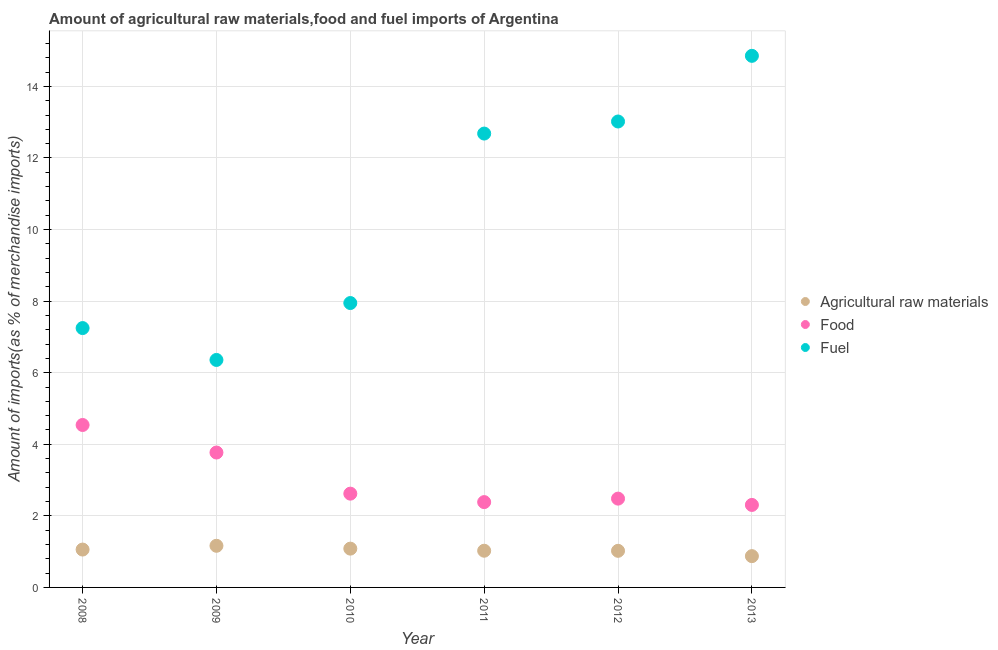How many different coloured dotlines are there?
Your response must be concise. 3. Is the number of dotlines equal to the number of legend labels?
Provide a succinct answer. Yes. What is the percentage of food imports in 2010?
Offer a terse response. 2.62. Across all years, what is the maximum percentage of food imports?
Make the answer very short. 4.54. Across all years, what is the minimum percentage of fuel imports?
Give a very brief answer. 6.36. In which year was the percentage of food imports maximum?
Provide a succinct answer. 2008. What is the total percentage of fuel imports in the graph?
Offer a terse response. 62.1. What is the difference between the percentage of fuel imports in 2012 and that in 2013?
Provide a short and direct response. -1.83. What is the difference between the percentage of raw materials imports in 2013 and the percentage of fuel imports in 2009?
Your answer should be very brief. -5.48. What is the average percentage of food imports per year?
Your answer should be compact. 3.02. In the year 2010, what is the difference between the percentage of fuel imports and percentage of food imports?
Your answer should be compact. 5.33. In how many years, is the percentage of fuel imports greater than 14.8 %?
Keep it short and to the point. 1. What is the ratio of the percentage of raw materials imports in 2009 to that in 2011?
Your answer should be very brief. 1.13. Is the difference between the percentage of fuel imports in 2008 and 2010 greater than the difference between the percentage of food imports in 2008 and 2010?
Offer a terse response. No. What is the difference between the highest and the second highest percentage of raw materials imports?
Give a very brief answer. 0.08. What is the difference between the highest and the lowest percentage of raw materials imports?
Your answer should be very brief. 0.29. Is the percentage of raw materials imports strictly greater than the percentage of fuel imports over the years?
Offer a terse response. No. How many dotlines are there?
Make the answer very short. 3. Does the graph contain any zero values?
Offer a terse response. No. Where does the legend appear in the graph?
Provide a succinct answer. Center right. How many legend labels are there?
Make the answer very short. 3. How are the legend labels stacked?
Make the answer very short. Vertical. What is the title of the graph?
Provide a succinct answer. Amount of agricultural raw materials,food and fuel imports of Argentina. What is the label or title of the X-axis?
Your answer should be compact. Year. What is the label or title of the Y-axis?
Make the answer very short. Amount of imports(as % of merchandise imports). What is the Amount of imports(as % of merchandise imports) in Agricultural raw materials in 2008?
Keep it short and to the point. 1.06. What is the Amount of imports(as % of merchandise imports) in Food in 2008?
Keep it short and to the point. 4.54. What is the Amount of imports(as % of merchandise imports) of Fuel in 2008?
Give a very brief answer. 7.25. What is the Amount of imports(as % of merchandise imports) of Agricultural raw materials in 2009?
Provide a succinct answer. 1.16. What is the Amount of imports(as % of merchandise imports) of Food in 2009?
Offer a very short reply. 3.77. What is the Amount of imports(as % of merchandise imports) in Fuel in 2009?
Your answer should be very brief. 6.36. What is the Amount of imports(as % of merchandise imports) of Agricultural raw materials in 2010?
Provide a succinct answer. 1.08. What is the Amount of imports(as % of merchandise imports) of Food in 2010?
Offer a terse response. 2.62. What is the Amount of imports(as % of merchandise imports) of Fuel in 2010?
Keep it short and to the point. 7.95. What is the Amount of imports(as % of merchandise imports) in Agricultural raw materials in 2011?
Offer a very short reply. 1.03. What is the Amount of imports(as % of merchandise imports) in Food in 2011?
Ensure brevity in your answer.  2.38. What is the Amount of imports(as % of merchandise imports) of Fuel in 2011?
Offer a terse response. 12.68. What is the Amount of imports(as % of merchandise imports) of Agricultural raw materials in 2012?
Make the answer very short. 1.02. What is the Amount of imports(as % of merchandise imports) of Food in 2012?
Give a very brief answer. 2.48. What is the Amount of imports(as % of merchandise imports) in Fuel in 2012?
Provide a short and direct response. 13.02. What is the Amount of imports(as % of merchandise imports) of Agricultural raw materials in 2013?
Provide a succinct answer. 0.87. What is the Amount of imports(as % of merchandise imports) of Food in 2013?
Ensure brevity in your answer.  2.31. What is the Amount of imports(as % of merchandise imports) of Fuel in 2013?
Offer a terse response. 14.85. Across all years, what is the maximum Amount of imports(as % of merchandise imports) of Agricultural raw materials?
Provide a succinct answer. 1.16. Across all years, what is the maximum Amount of imports(as % of merchandise imports) in Food?
Provide a succinct answer. 4.54. Across all years, what is the maximum Amount of imports(as % of merchandise imports) in Fuel?
Keep it short and to the point. 14.85. Across all years, what is the minimum Amount of imports(as % of merchandise imports) of Agricultural raw materials?
Your answer should be very brief. 0.87. Across all years, what is the minimum Amount of imports(as % of merchandise imports) of Food?
Offer a terse response. 2.31. Across all years, what is the minimum Amount of imports(as % of merchandise imports) in Fuel?
Provide a succinct answer. 6.36. What is the total Amount of imports(as % of merchandise imports) in Agricultural raw materials in the graph?
Provide a succinct answer. 6.23. What is the total Amount of imports(as % of merchandise imports) in Food in the graph?
Keep it short and to the point. 18.1. What is the total Amount of imports(as % of merchandise imports) in Fuel in the graph?
Give a very brief answer. 62.1. What is the difference between the Amount of imports(as % of merchandise imports) of Agricultural raw materials in 2008 and that in 2009?
Give a very brief answer. -0.11. What is the difference between the Amount of imports(as % of merchandise imports) in Food in 2008 and that in 2009?
Make the answer very short. 0.77. What is the difference between the Amount of imports(as % of merchandise imports) of Fuel in 2008 and that in 2009?
Provide a succinct answer. 0.89. What is the difference between the Amount of imports(as % of merchandise imports) in Agricultural raw materials in 2008 and that in 2010?
Provide a short and direct response. -0.03. What is the difference between the Amount of imports(as % of merchandise imports) of Food in 2008 and that in 2010?
Your response must be concise. 1.92. What is the difference between the Amount of imports(as % of merchandise imports) of Fuel in 2008 and that in 2010?
Your answer should be compact. -0.7. What is the difference between the Amount of imports(as % of merchandise imports) in Agricultural raw materials in 2008 and that in 2011?
Make the answer very short. 0.03. What is the difference between the Amount of imports(as % of merchandise imports) of Food in 2008 and that in 2011?
Your response must be concise. 2.15. What is the difference between the Amount of imports(as % of merchandise imports) of Fuel in 2008 and that in 2011?
Your response must be concise. -5.43. What is the difference between the Amount of imports(as % of merchandise imports) of Agricultural raw materials in 2008 and that in 2012?
Make the answer very short. 0.04. What is the difference between the Amount of imports(as % of merchandise imports) of Food in 2008 and that in 2012?
Offer a very short reply. 2.06. What is the difference between the Amount of imports(as % of merchandise imports) in Fuel in 2008 and that in 2012?
Keep it short and to the point. -5.77. What is the difference between the Amount of imports(as % of merchandise imports) of Agricultural raw materials in 2008 and that in 2013?
Ensure brevity in your answer.  0.18. What is the difference between the Amount of imports(as % of merchandise imports) of Food in 2008 and that in 2013?
Your answer should be very brief. 2.23. What is the difference between the Amount of imports(as % of merchandise imports) in Fuel in 2008 and that in 2013?
Offer a terse response. -7.61. What is the difference between the Amount of imports(as % of merchandise imports) in Agricultural raw materials in 2009 and that in 2010?
Offer a very short reply. 0.08. What is the difference between the Amount of imports(as % of merchandise imports) in Food in 2009 and that in 2010?
Offer a terse response. 1.15. What is the difference between the Amount of imports(as % of merchandise imports) in Fuel in 2009 and that in 2010?
Keep it short and to the point. -1.59. What is the difference between the Amount of imports(as % of merchandise imports) of Agricultural raw materials in 2009 and that in 2011?
Ensure brevity in your answer.  0.14. What is the difference between the Amount of imports(as % of merchandise imports) in Food in 2009 and that in 2011?
Your answer should be very brief. 1.39. What is the difference between the Amount of imports(as % of merchandise imports) in Fuel in 2009 and that in 2011?
Keep it short and to the point. -6.33. What is the difference between the Amount of imports(as % of merchandise imports) in Agricultural raw materials in 2009 and that in 2012?
Your answer should be very brief. 0.14. What is the difference between the Amount of imports(as % of merchandise imports) in Food in 2009 and that in 2012?
Provide a succinct answer. 1.29. What is the difference between the Amount of imports(as % of merchandise imports) of Fuel in 2009 and that in 2012?
Make the answer very short. -6.66. What is the difference between the Amount of imports(as % of merchandise imports) in Agricultural raw materials in 2009 and that in 2013?
Make the answer very short. 0.29. What is the difference between the Amount of imports(as % of merchandise imports) in Food in 2009 and that in 2013?
Your response must be concise. 1.46. What is the difference between the Amount of imports(as % of merchandise imports) of Fuel in 2009 and that in 2013?
Make the answer very short. -8.5. What is the difference between the Amount of imports(as % of merchandise imports) in Agricultural raw materials in 2010 and that in 2011?
Ensure brevity in your answer.  0.06. What is the difference between the Amount of imports(as % of merchandise imports) in Food in 2010 and that in 2011?
Ensure brevity in your answer.  0.24. What is the difference between the Amount of imports(as % of merchandise imports) of Fuel in 2010 and that in 2011?
Your answer should be very brief. -4.74. What is the difference between the Amount of imports(as % of merchandise imports) in Agricultural raw materials in 2010 and that in 2012?
Offer a terse response. 0.06. What is the difference between the Amount of imports(as % of merchandise imports) of Food in 2010 and that in 2012?
Make the answer very short. 0.14. What is the difference between the Amount of imports(as % of merchandise imports) of Fuel in 2010 and that in 2012?
Ensure brevity in your answer.  -5.07. What is the difference between the Amount of imports(as % of merchandise imports) in Agricultural raw materials in 2010 and that in 2013?
Offer a terse response. 0.21. What is the difference between the Amount of imports(as % of merchandise imports) in Food in 2010 and that in 2013?
Your answer should be compact. 0.32. What is the difference between the Amount of imports(as % of merchandise imports) in Fuel in 2010 and that in 2013?
Your answer should be compact. -6.91. What is the difference between the Amount of imports(as % of merchandise imports) in Agricultural raw materials in 2011 and that in 2012?
Your answer should be very brief. 0. What is the difference between the Amount of imports(as % of merchandise imports) of Food in 2011 and that in 2012?
Offer a very short reply. -0.1. What is the difference between the Amount of imports(as % of merchandise imports) in Fuel in 2011 and that in 2012?
Your answer should be compact. -0.34. What is the difference between the Amount of imports(as % of merchandise imports) of Agricultural raw materials in 2011 and that in 2013?
Your answer should be compact. 0.15. What is the difference between the Amount of imports(as % of merchandise imports) in Food in 2011 and that in 2013?
Provide a short and direct response. 0.08. What is the difference between the Amount of imports(as % of merchandise imports) in Fuel in 2011 and that in 2013?
Keep it short and to the point. -2.17. What is the difference between the Amount of imports(as % of merchandise imports) of Agricultural raw materials in 2012 and that in 2013?
Ensure brevity in your answer.  0.15. What is the difference between the Amount of imports(as % of merchandise imports) of Food in 2012 and that in 2013?
Offer a terse response. 0.18. What is the difference between the Amount of imports(as % of merchandise imports) of Fuel in 2012 and that in 2013?
Make the answer very short. -1.83. What is the difference between the Amount of imports(as % of merchandise imports) in Agricultural raw materials in 2008 and the Amount of imports(as % of merchandise imports) in Food in 2009?
Provide a short and direct response. -2.71. What is the difference between the Amount of imports(as % of merchandise imports) in Agricultural raw materials in 2008 and the Amount of imports(as % of merchandise imports) in Fuel in 2009?
Ensure brevity in your answer.  -5.3. What is the difference between the Amount of imports(as % of merchandise imports) of Food in 2008 and the Amount of imports(as % of merchandise imports) of Fuel in 2009?
Provide a succinct answer. -1.82. What is the difference between the Amount of imports(as % of merchandise imports) of Agricultural raw materials in 2008 and the Amount of imports(as % of merchandise imports) of Food in 2010?
Ensure brevity in your answer.  -1.56. What is the difference between the Amount of imports(as % of merchandise imports) in Agricultural raw materials in 2008 and the Amount of imports(as % of merchandise imports) in Fuel in 2010?
Provide a short and direct response. -6.89. What is the difference between the Amount of imports(as % of merchandise imports) of Food in 2008 and the Amount of imports(as % of merchandise imports) of Fuel in 2010?
Your response must be concise. -3.41. What is the difference between the Amount of imports(as % of merchandise imports) of Agricultural raw materials in 2008 and the Amount of imports(as % of merchandise imports) of Food in 2011?
Ensure brevity in your answer.  -1.33. What is the difference between the Amount of imports(as % of merchandise imports) of Agricultural raw materials in 2008 and the Amount of imports(as % of merchandise imports) of Fuel in 2011?
Provide a short and direct response. -11.62. What is the difference between the Amount of imports(as % of merchandise imports) of Food in 2008 and the Amount of imports(as % of merchandise imports) of Fuel in 2011?
Your answer should be very brief. -8.14. What is the difference between the Amount of imports(as % of merchandise imports) in Agricultural raw materials in 2008 and the Amount of imports(as % of merchandise imports) in Food in 2012?
Offer a very short reply. -1.42. What is the difference between the Amount of imports(as % of merchandise imports) of Agricultural raw materials in 2008 and the Amount of imports(as % of merchandise imports) of Fuel in 2012?
Your answer should be compact. -11.96. What is the difference between the Amount of imports(as % of merchandise imports) in Food in 2008 and the Amount of imports(as % of merchandise imports) in Fuel in 2012?
Ensure brevity in your answer.  -8.48. What is the difference between the Amount of imports(as % of merchandise imports) of Agricultural raw materials in 2008 and the Amount of imports(as % of merchandise imports) of Food in 2013?
Offer a very short reply. -1.25. What is the difference between the Amount of imports(as % of merchandise imports) of Agricultural raw materials in 2008 and the Amount of imports(as % of merchandise imports) of Fuel in 2013?
Offer a terse response. -13.8. What is the difference between the Amount of imports(as % of merchandise imports) of Food in 2008 and the Amount of imports(as % of merchandise imports) of Fuel in 2013?
Offer a very short reply. -10.31. What is the difference between the Amount of imports(as % of merchandise imports) in Agricultural raw materials in 2009 and the Amount of imports(as % of merchandise imports) in Food in 2010?
Provide a short and direct response. -1.46. What is the difference between the Amount of imports(as % of merchandise imports) of Agricultural raw materials in 2009 and the Amount of imports(as % of merchandise imports) of Fuel in 2010?
Your answer should be very brief. -6.78. What is the difference between the Amount of imports(as % of merchandise imports) of Food in 2009 and the Amount of imports(as % of merchandise imports) of Fuel in 2010?
Provide a succinct answer. -4.18. What is the difference between the Amount of imports(as % of merchandise imports) in Agricultural raw materials in 2009 and the Amount of imports(as % of merchandise imports) in Food in 2011?
Provide a short and direct response. -1.22. What is the difference between the Amount of imports(as % of merchandise imports) in Agricultural raw materials in 2009 and the Amount of imports(as % of merchandise imports) in Fuel in 2011?
Your response must be concise. -11.52. What is the difference between the Amount of imports(as % of merchandise imports) of Food in 2009 and the Amount of imports(as % of merchandise imports) of Fuel in 2011?
Make the answer very short. -8.91. What is the difference between the Amount of imports(as % of merchandise imports) in Agricultural raw materials in 2009 and the Amount of imports(as % of merchandise imports) in Food in 2012?
Offer a very short reply. -1.32. What is the difference between the Amount of imports(as % of merchandise imports) of Agricultural raw materials in 2009 and the Amount of imports(as % of merchandise imports) of Fuel in 2012?
Offer a very short reply. -11.86. What is the difference between the Amount of imports(as % of merchandise imports) in Food in 2009 and the Amount of imports(as % of merchandise imports) in Fuel in 2012?
Give a very brief answer. -9.25. What is the difference between the Amount of imports(as % of merchandise imports) in Agricultural raw materials in 2009 and the Amount of imports(as % of merchandise imports) in Food in 2013?
Give a very brief answer. -1.14. What is the difference between the Amount of imports(as % of merchandise imports) of Agricultural raw materials in 2009 and the Amount of imports(as % of merchandise imports) of Fuel in 2013?
Provide a succinct answer. -13.69. What is the difference between the Amount of imports(as % of merchandise imports) in Food in 2009 and the Amount of imports(as % of merchandise imports) in Fuel in 2013?
Keep it short and to the point. -11.08. What is the difference between the Amount of imports(as % of merchandise imports) in Agricultural raw materials in 2010 and the Amount of imports(as % of merchandise imports) in Food in 2011?
Provide a succinct answer. -1.3. What is the difference between the Amount of imports(as % of merchandise imports) of Agricultural raw materials in 2010 and the Amount of imports(as % of merchandise imports) of Fuel in 2011?
Provide a succinct answer. -11.6. What is the difference between the Amount of imports(as % of merchandise imports) of Food in 2010 and the Amount of imports(as % of merchandise imports) of Fuel in 2011?
Your response must be concise. -10.06. What is the difference between the Amount of imports(as % of merchandise imports) in Agricultural raw materials in 2010 and the Amount of imports(as % of merchandise imports) in Food in 2012?
Your answer should be very brief. -1.4. What is the difference between the Amount of imports(as % of merchandise imports) of Agricultural raw materials in 2010 and the Amount of imports(as % of merchandise imports) of Fuel in 2012?
Your answer should be compact. -11.94. What is the difference between the Amount of imports(as % of merchandise imports) in Food in 2010 and the Amount of imports(as % of merchandise imports) in Fuel in 2012?
Provide a short and direct response. -10.4. What is the difference between the Amount of imports(as % of merchandise imports) in Agricultural raw materials in 2010 and the Amount of imports(as % of merchandise imports) in Food in 2013?
Your response must be concise. -1.22. What is the difference between the Amount of imports(as % of merchandise imports) in Agricultural raw materials in 2010 and the Amount of imports(as % of merchandise imports) in Fuel in 2013?
Keep it short and to the point. -13.77. What is the difference between the Amount of imports(as % of merchandise imports) in Food in 2010 and the Amount of imports(as % of merchandise imports) in Fuel in 2013?
Keep it short and to the point. -12.23. What is the difference between the Amount of imports(as % of merchandise imports) of Agricultural raw materials in 2011 and the Amount of imports(as % of merchandise imports) of Food in 2012?
Your answer should be very brief. -1.46. What is the difference between the Amount of imports(as % of merchandise imports) of Agricultural raw materials in 2011 and the Amount of imports(as % of merchandise imports) of Fuel in 2012?
Give a very brief answer. -11.99. What is the difference between the Amount of imports(as % of merchandise imports) in Food in 2011 and the Amount of imports(as % of merchandise imports) in Fuel in 2012?
Provide a short and direct response. -10.64. What is the difference between the Amount of imports(as % of merchandise imports) in Agricultural raw materials in 2011 and the Amount of imports(as % of merchandise imports) in Food in 2013?
Your response must be concise. -1.28. What is the difference between the Amount of imports(as % of merchandise imports) in Agricultural raw materials in 2011 and the Amount of imports(as % of merchandise imports) in Fuel in 2013?
Your answer should be compact. -13.83. What is the difference between the Amount of imports(as % of merchandise imports) of Food in 2011 and the Amount of imports(as % of merchandise imports) of Fuel in 2013?
Your response must be concise. -12.47. What is the difference between the Amount of imports(as % of merchandise imports) in Agricultural raw materials in 2012 and the Amount of imports(as % of merchandise imports) in Food in 2013?
Your answer should be very brief. -1.28. What is the difference between the Amount of imports(as % of merchandise imports) in Agricultural raw materials in 2012 and the Amount of imports(as % of merchandise imports) in Fuel in 2013?
Give a very brief answer. -13.83. What is the difference between the Amount of imports(as % of merchandise imports) of Food in 2012 and the Amount of imports(as % of merchandise imports) of Fuel in 2013?
Keep it short and to the point. -12.37. What is the average Amount of imports(as % of merchandise imports) of Agricultural raw materials per year?
Your response must be concise. 1.04. What is the average Amount of imports(as % of merchandise imports) in Food per year?
Provide a short and direct response. 3.02. What is the average Amount of imports(as % of merchandise imports) in Fuel per year?
Give a very brief answer. 10.35. In the year 2008, what is the difference between the Amount of imports(as % of merchandise imports) of Agricultural raw materials and Amount of imports(as % of merchandise imports) of Food?
Provide a succinct answer. -3.48. In the year 2008, what is the difference between the Amount of imports(as % of merchandise imports) of Agricultural raw materials and Amount of imports(as % of merchandise imports) of Fuel?
Provide a short and direct response. -6.19. In the year 2008, what is the difference between the Amount of imports(as % of merchandise imports) in Food and Amount of imports(as % of merchandise imports) in Fuel?
Your response must be concise. -2.71. In the year 2009, what is the difference between the Amount of imports(as % of merchandise imports) in Agricultural raw materials and Amount of imports(as % of merchandise imports) in Food?
Keep it short and to the point. -2.61. In the year 2009, what is the difference between the Amount of imports(as % of merchandise imports) in Agricultural raw materials and Amount of imports(as % of merchandise imports) in Fuel?
Give a very brief answer. -5.19. In the year 2009, what is the difference between the Amount of imports(as % of merchandise imports) of Food and Amount of imports(as % of merchandise imports) of Fuel?
Offer a terse response. -2.59. In the year 2010, what is the difference between the Amount of imports(as % of merchandise imports) of Agricultural raw materials and Amount of imports(as % of merchandise imports) of Food?
Offer a very short reply. -1.54. In the year 2010, what is the difference between the Amount of imports(as % of merchandise imports) of Agricultural raw materials and Amount of imports(as % of merchandise imports) of Fuel?
Ensure brevity in your answer.  -6.86. In the year 2010, what is the difference between the Amount of imports(as % of merchandise imports) of Food and Amount of imports(as % of merchandise imports) of Fuel?
Provide a short and direct response. -5.33. In the year 2011, what is the difference between the Amount of imports(as % of merchandise imports) in Agricultural raw materials and Amount of imports(as % of merchandise imports) in Food?
Keep it short and to the point. -1.36. In the year 2011, what is the difference between the Amount of imports(as % of merchandise imports) of Agricultural raw materials and Amount of imports(as % of merchandise imports) of Fuel?
Keep it short and to the point. -11.66. In the year 2011, what is the difference between the Amount of imports(as % of merchandise imports) in Food and Amount of imports(as % of merchandise imports) in Fuel?
Ensure brevity in your answer.  -10.3. In the year 2012, what is the difference between the Amount of imports(as % of merchandise imports) of Agricultural raw materials and Amount of imports(as % of merchandise imports) of Food?
Ensure brevity in your answer.  -1.46. In the year 2012, what is the difference between the Amount of imports(as % of merchandise imports) in Agricultural raw materials and Amount of imports(as % of merchandise imports) in Fuel?
Offer a very short reply. -12. In the year 2012, what is the difference between the Amount of imports(as % of merchandise imports) of Food and Amount of imports(as % of merchandise imports) of Fuel?
Make the answer very short. -10.54. In the year 2013, what is the difference between the Amount of imports(as % of merchandise imports) in Agricultural raw materials and Amount of imports(as % of merchandise imports) in Food?
Your response must be concise. -1.43. In the year 2013, what is the difference between the Amount of imports(as % of merchandise imports) of Agricultural raw materials and Amount of imports(as % of merchandise imports) of Fuel?
Your answer should be very brief. -13.98. In the year 2013, what is the difference between the Amount of imports(as % of merchandise imports) in Food and Amount of imports(as % of merchandise imports) in Fuel?
Give a very brief answer. -12.55. What is the ratio of the Amount of imports(as % of merchandise imports) in Agricultural raw materials in 2008 to that in 2009?
Offer a terse response. 0.91. What is the ratio of the Amount of imports(as % of merchandise imports) in Food in 2008 to that in 2009?
Provide a short and direct response. 1.2. What is the ratio of the Amount of imports(as % of merchandise imports) of Fuel in 2008 to that in 2009?
Keep it short and to the point. 1.14. What is the ratio of the Amount of imports(as % of merchandise imports) in Agricultural raw materials in 2008 to that in 2010?
Keep it short and to the point. 0.98. What is the ratio of the Amount of imports(as % of merchandise imports) of Food in 2008 to that in 2010?
Keep it short and to the point. 1.73. What is the ratio of the Amount of imports(as % of merchandise imports) of Fuel in 2008 to that in 2010?
Your response must be concise. 0.91. What is the ratio of the Amount of imports(as % of merchandise imports) in Agricultural raw materials in 2008 to that in 2011?
Keep it short and to the point. 1.03. What is the ratio of the Amount of imports(as % of merchandise imports) in Food in 2008 to that in 2011?
Give a very brief answer. 1.9. What is the ratio of the Amount of imports(as % of merchandise imports) of Fuel in 2008 to that in 2011?
Your response must be concise. 0.57. What is the ratio of the Amount of imports(as % of merchandise imports) in Agricultural raw materials in 2008 to that in 2012?
Your answer should be very brief. 1.03. What is the ratio of the Amount of imports(as % of merchandise imports) in Food in 2008 to that in 2012?
Your response must be concise. 1.83. What is the ratio of the Amount of imports(as % of merchandise imports) in Fuel in 2008 to that in 2012?
Make the answer very short. 0.56. What is the ratio of the Amount of imports(as % of merchandise imports) in Agricultural raw materials in 2008 to that in 2013?
Give a very brief answer. 1.21. What is the ratio of the Amount of imports(as % of merchandise imports) in Food in 2008 to that in 2013?
Your response must be concise. 1.97. What is the ratio of the Amount of imports(as % of merchandise imports) of Fuel in 2008 to that in 2013?
Provide a succinct answer. 0.49. What is the ratio of the Amount of imports(as % of merchandise imports) in Agricultural raw materials in 2009 to that in 2010?
Your answer should be very brief. 1.07. What is the ratio of the Amount of imports(as % of merchandise imports) in Food in 2009 to that in 2010?
Keep it short and to the point. 1.44. What is the ratio of the Amount of imports(as % of merchandise imports) of Fuel in 2009 to that in 2010?
Your answer should be very brief. 0.8. What is the ratio of the Amount of imports(as % of merchandise imports) in Agricultural raw materials in 2009 to that in 2011?
Your answer should be very brief. 1.13. What is the ratio of the Amount of imports(as % of merchandise imports) in Food in 2009 to that in 2011?
Keep it short and to the point. 1.58. What is the ratio of the Amount of imports(as % of merchandise imports) in Fuel in 2009 to that in 2011?
Your answer should be very brief. 0.5. What is the ratio of the Amount of imports(as % of merchandise imports) in Agricultural raw materials in 2009 to that in 2012?
Provide a short and direct response. 1.14. What is the ratio of the Amount of imports(as % of merchandise imports) in Food in 2009 to that in 2012?
Keep it short and to the point. 1.52. What is the ratio of the Amount of imports(as % of merchandise imports) in Fuel in 2009 to that in 2012?
Keep it short and to the point. 0.49. What is the ratio of the Amount of imports(as % of merchandise imports) in Agricultural raw materials in 2009 to that in 2013?
Provide a short and direct response. 1.33. What is the ratio of the Amount of imports(as % of merchandise imports) in Food in 2009 to that in 2013?
Provide a short and direct response. 1.64. What is the ratio of the Amount of imports(as % of merchandise imports) of Fuel in 2009 to that in 2013?
Provide a short and direct response. 0.43. What is the ratio of the Amount of imports(as % of merchandise imports) in Agricultural raw materials in 2010 to that in 2011?
Your response must be concise. 1.06. What is the ratio of the Amount of imports(as % of merchandise imports) in Food in 2010 to that in 2011?
Your answer should be very brief. 1.1. What is the ratio of the Amount of imports(as % of merchandise imports) of Fuel in 2010 to that in 2011?
Your response must be concise. 0.63. What is the ratio of the Amount of imports(as % of merchandise imports) of Agricultural raw materials in 2010 to that in 2012?
Your answer should be very brief. 1.06. What is the ratio of the Amount of imports(as % of merchandise imports) of Food in 2010 to that in 2012?
Ensure brevity in your answer.  1.06. What is the ratio of the Amount of imports(as % of merchandise imports) in Fuel in 2010 to that in 2012?
Make the answer very short. 0.61. What is the ratio of the Amount of imports(as % of merchandise imports) of Agricultural raw materials in 2010 to that in 2013?
Offer a terse response. 1.24. What is the ratio of the Amount of imports(as % of merchandise imports) in Food in 2010 to that in 2013?
Keep it short and to the point. 1.14. What is the ratio of the Amount of imports(as % of merchandise imports) in Fuel in 2010 to that in 2013?
Your answer should be very brief. 0.54. What is the ratio of the Amount of imports(as % of merchandise imports) of Agricultural raw materials in 2011 to that in 2012?
Keep it short and to the point. 1. What is the ratio of the Amount of imports(as % of merchandise imports) of Food in 2011 to that in 2012?
Give a very brief answer. 0.96. What is the ratio of the Amount of imports(as % of merchandise imports) in Fuel in 2011 to that in 2012?
Make the answer very short. 0.97. What is the ratio of the Amount of imports(as % of merchandise imports) of Agricultural raw materials in 2011 to that in 2013?
Give a very brief answer. 1.17. What is the ratio of the Amount of imports(as % of merchandise imports) of Food in 2011 to that in 2013?
Ensure brevity in your answer.  1.03. What is the ratio of the Amount of imports(as % of merchandise imports) of Fuel in 2011 to that in 2013?
Offer a very short reply. 0.85. What is the ratio of the Amount of imports(as % of merchandise imports) in Agricultural raw materials in 2012 to that in 2013?
Make the answer very short. 1.17. What is the ratio of the Amount of imports(as % of merchandise imports) in Food in 2012 to that in 2013?
Your response must be concise. 1.08. What is the ratio of the Amount of imports(as % of merchandise imports) in Fuel in 2012 to that in 2013?
Give a very brief answer. 0.88. What is the difference between the highest and the second highest Amount of imports(as % of merchandise imports) in Agricultural raw materials?
Make the answer very short. 0.08. What is the difference between the highest and the second highest Amount of imports(as % of merchandise imports) in Food?
Offer a terse response. 0.77. What is the difference between the highest and the second highest Amount of imports(as % of merchandise imports) of Fuel?
Keep it short and to the point. 1.83. What is the difference between the highest and the lowest Amount of imports(as % of merchandise imports) in Agricultural raw materials?
Keep it short and to the point. 0.29. What is the difference between the highest and the lowest Amount of imports(as % of merchandise imports) in Food?
Provide a succinct answer. 2.23. What is the difference between the highest and the lowest Amount of imports(as % of merchandise imports) in Fuel?
Provide a succinct answer. 8.5. 